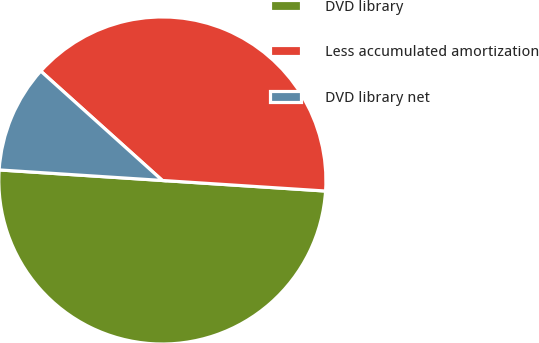<chart> <loc_0><loc_0><loc_500><loc_500><pie_chart><fcel>DVD library<fcel>Less accumulated amortization<fcel>DVD library net<nl><fcel>50.0%<fcel>39.37%<fcel>10.63%<nl></chart> 